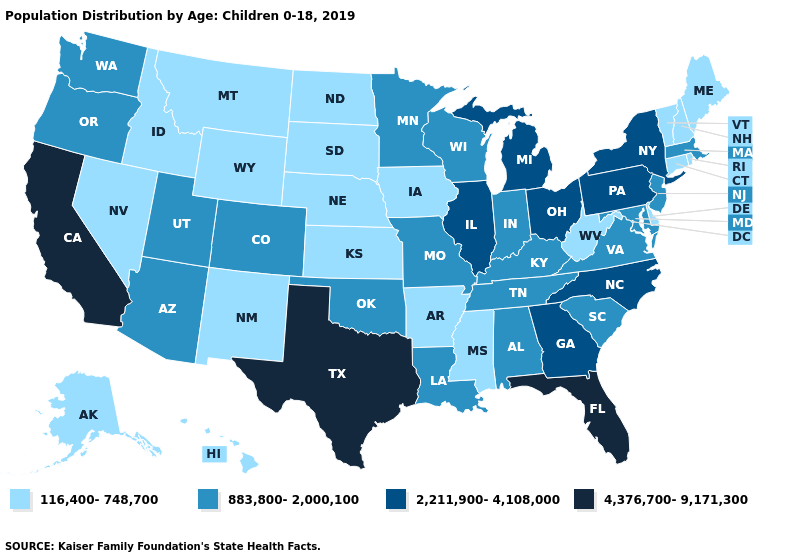What is the lowest value in the South?
Write a very short answer. 116,400-748,700. Name the states that have a value in the range 4,376,700-9,171,300?
Short answer required. California, Florida, Texas. What is the lowest value in the USA?
Write a very short answer. 116,400-748,700. Does the map have missing data?
Give a very brief answer. No. Which states have the highest value in the USA?
Write a very short answer. California, Florida, Texas. Name the states that have a value in the range 116,400-748,700?
Write a very short answer. Alaska, Arkansas, Connecticut, Delaware, Hawaii, Idaho, Iowa, Kansas, Maine, Mississippi, Montana, Nebraska, Nevada, New Hampshire, New Mexico, North Dakota, Rhode Island, South Dakota, Vermont, West Virginia, Wyoming. What is the highest value in states that border Delaware?
Write a very short answer. 2,211,900-4,108,000. What is the lowest value in the USA?
Short answer required. 116,400-748,700. Does Vermont have the lowest value in the Northeast?
Quick response, please. Yes. What is the highest value in the South ?
Answer briefly. 4,376,700-9,171,300. Which states hav the highest value in the Northeast?
Concise answer only. New York, Pennsylvania. What is the lowest value in the South?
Be succinct. 116,400-748,700. What is the value of Virginia?
Write a very short answer. 883,800-2,000,100. Among the states that border Arizona , which have the highest value?
Answer briefly. California. Does Ohio have the lowest value in the MidWest?
Give a very brief answer. No. 